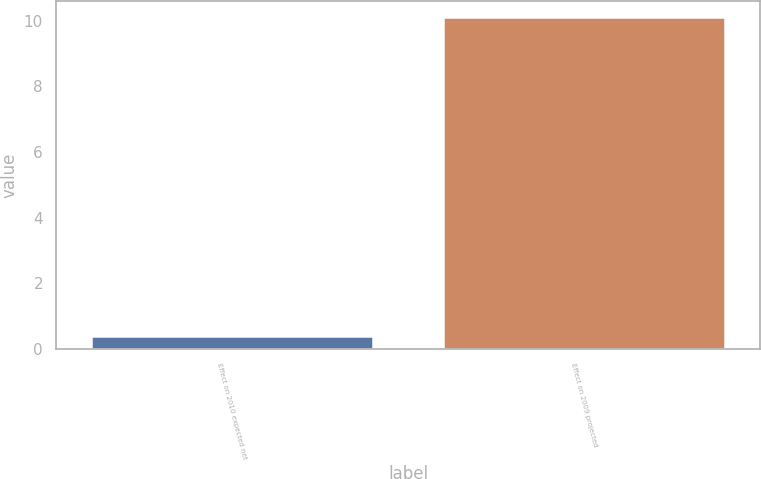Convert chart. <chart><loc_0><loc_0><loc_500><loc_500><bar_chart><fcel>Effect on 2010 expected net<fcel>Effect on 2009 projected<nl><fcel>0.4<fcel>10.1<nl></chart> 